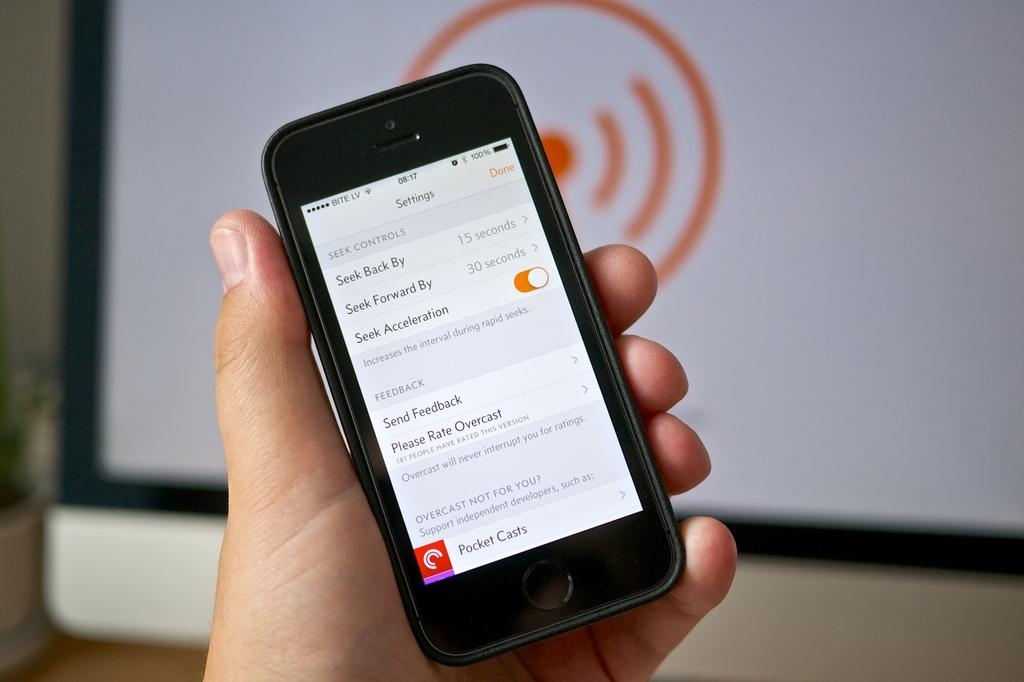<image>
Relay a brief, clear account of the picture shown. The settings menu of a Bite Lv serviced cell phone. 